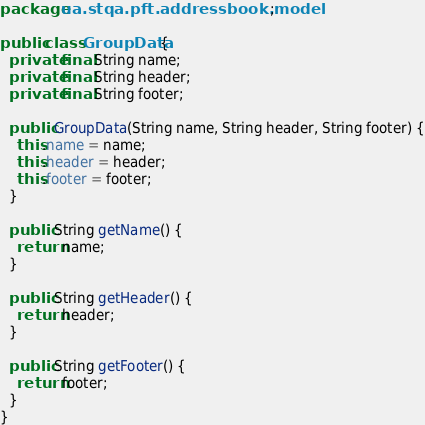<code> <loc_0><loc_0><loc_500><loc_500><_Java_>package ua.stqa.pft.addressbook.model;

public class GroupData {
  private final String name;
  private final String header;
  private final String footer;

  public GroupData(String name, String header, String footer) {
    this.name = name;
    this.header = header;
    this.footer = footer;
  }

  public String getName() {
    return name;
  }

  public String getHeader() {
    return header;
  }

  public String getFooter() {
    return footer;
  }
}
</code> 